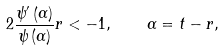Convert formula to latex. <formula><loc_0><loc_0><loc_500><loc_500>2 \frac { { \psi } ^ { \prime } \left ( \alpha \right ) } { \psi \left ( \alpha \right ) } r < - 1 , \quad \alpha = t - r ,</formula> 